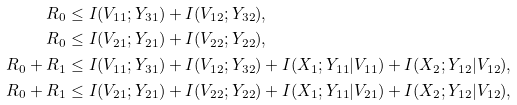<formula> <loc_0><loc_0><loc_500><loc_500>R _ { 0 } & \leq I ( V _ { 1 1 } ; Y _ { 3 1 } ) + I ( V _ { 1 2 } ; Y _ { 3 2 } ) , \\ R _ { 0 } & \leq I ( V _ { 2 1 } ; Y _ { 2 1 } ) + I ( V _ { 2 2 } ; Y _ { 2 2 } ) , \\ R _ { 0 } + R _ { 1 } & \leq I ( V _ { 1 1 } ; Y _ { 3 1 } ) + I ( V _ { 1 2 } ; Y _ { 3 2 } ) + I ( X _ { 1 } ; Y _ { 1 1 } | V _ { 1 1 } ) + I ( X _ { 2 } ; Y _ { 1 2 } | V _ { 1 2 } ) , \\ R _ { 0 } + R _ { 1 } & \leq I ( V _ { 2 1 } ; Y _ { 2 1 } ) + I ( V _ { 2 2 } ; Y _ { 2 2 } ) + I ( X _ { 1 } ; Y _ { 1 1 } | V _ { 2 1 } ) + I ( X _ { 2 } ; Y _ { 1 2 } | V _ { 1 2 } ) ,</formula> 